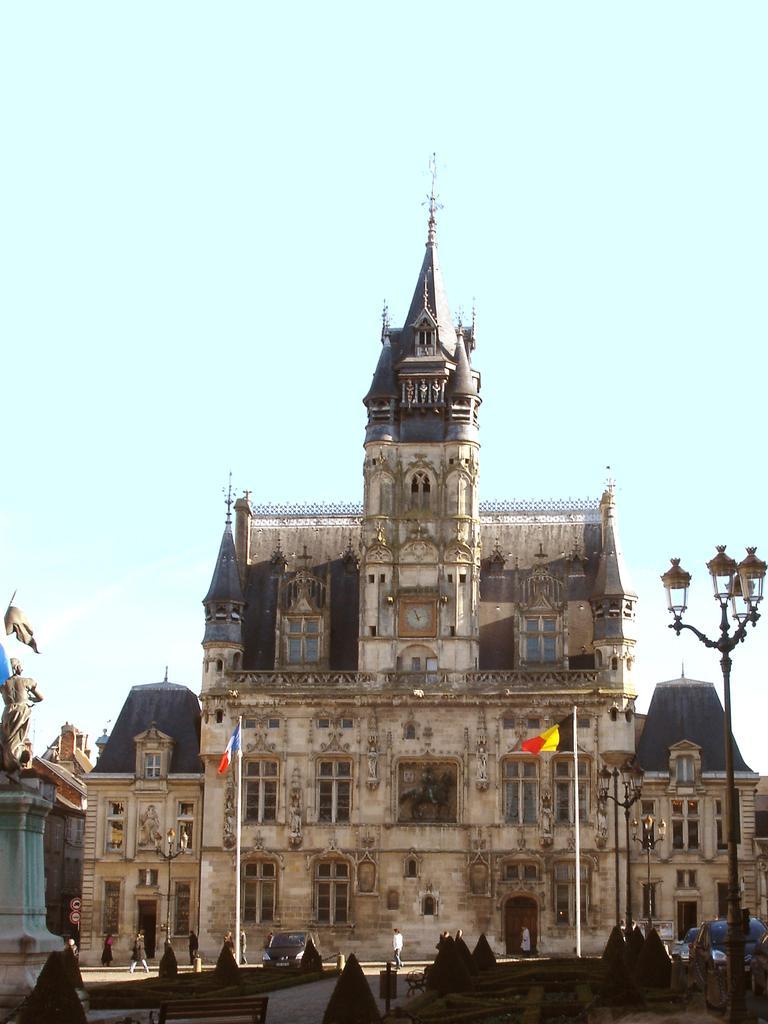Describe this image in one or two sentences. In the image I can see buildings, flags, a statue, streetlights and people on the ground. In the background I can see the sky. 